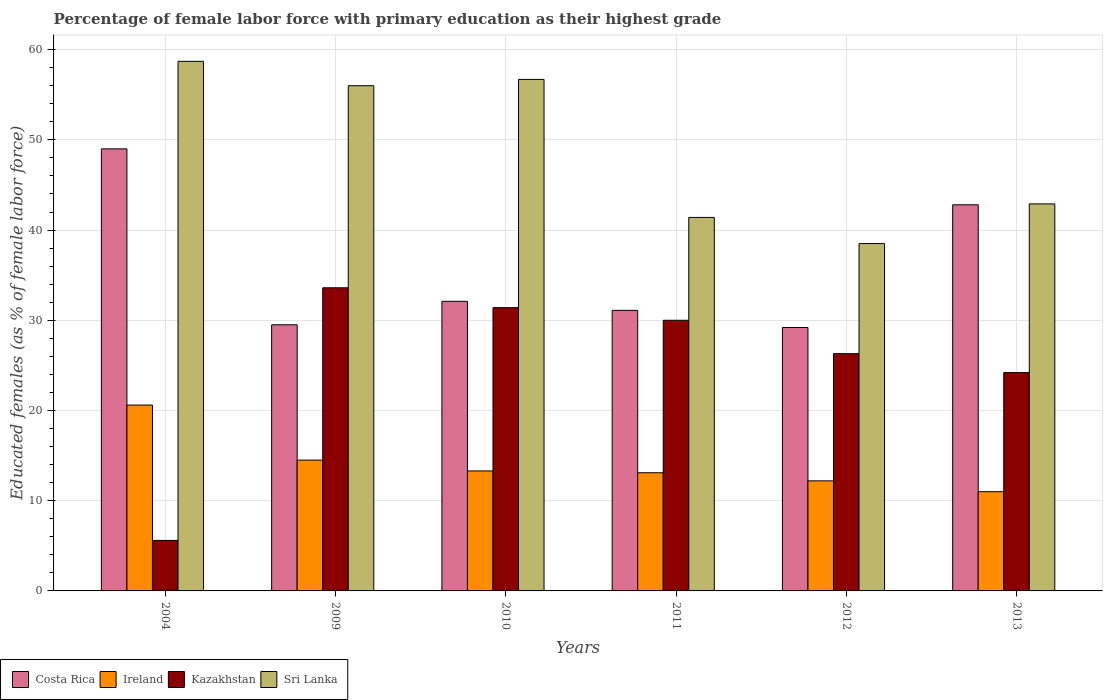How many groups of bars are there?
Your response must be concise. 6. What is the label of the 3rd group of bars from the left?
Your response must be concise. 2010. In how many cases, is the number of bars for a given year not equal to the number of legend labels?
Provide a succinct answer. 0. What is the percentage of female labor force with primary education in Costa Rica in 2010?
Keep it short and to the point. 32.1. Across all years, what is the maximum percentage of female labor force with primary education in Sri Lanka?
Keep it short and to the point. 58.7. Across all years, what is the minimum percentage of female labor force with primary education in Kazakhstan?
Provide a succinct answer. 5.6. In which year was the percentage of female labor force with primary education in Kazakhstan maximum?
Give a very brief answer. 2009. In which year was the percentage of female labor force with primary education in Costa Rica minimum?
Your answer should be compact. 2012. What is the total percentage of female labor force with primary education in Ireland in the graph?
Your answer should be compact. 84.7. What is the difference between the percentage of female labor force with primary education in Ireland in 2010 and that in 2011?
Offer a terse response. 0.2. What is the difference between the percentage of female labor force with primary education in Ireland in 2011 and the percentage of female labor force with primary education in Costa Rica in 2004?
Give a very brief answer. -35.9. What is the average percentage of female labor force with primary education in Costa Rica per year?
Offer a terse response. 35.62. In the year 2004, what is the difference between the percentage of female labor force with primary education in Sri Lanka and percentage of female labor force with primary education in Ireland?
Offer a terse response. 38.1. In how many years, is the percentage of female labor force with primary education in Ireland greater than 26 %?
Give a very brief answer. 0. What is the ratio of the percentage of female labor force with primary education in Sri Lanka in 2009 to that in 2011?
Provide a succinct answer. 1.35. Is the difference between the percentage of female labor force with primary education in Sri Lanka in 2009 and 2010 greater than the difference between the percentage of female labor force with primary education in Ireland in 2009 and 2010?
Provide a succinct answer. No. What is the difference between the highest and the second highest percentage of female labor force with primary education in Costa Rica?
Your answer should be very brief. 6.2. What is the difference between the highest and the lowest percentage of female labor force with primary education in Ireland?
Ensure brevity in your answer.  9.6. Is the sum of the percentage of female labor force with primary education in Sri Lanka in 2004 and 2010 greater than the maximum percentage of female labor force with primary education in Kazakhstan across all years?
Your response must be concise. Yes. Is it the case that in every year, the sum of the percentage of female labor force with primary education in Costa Rica and percentage of female labor force with primary education in Kazakhstan is greater than the sum of percentage of female labor force with primary education in Sri Lanka and percentage of female labor force with primary education in Ireland?
Keep it short and to the point. Yes. What does the 1st bar from the right in 2013 represents?
Provide a short and direct response. Sri Lanka. How many bars are there?
Your answer should be compact. 24. What is the difference between two consecutive major ticks on the Y-axis?
Ensure brevity in your answer.  10. Does the graph contain grids?
Keep it short and to the point. Yes. Where does the legend appear in the graph?
Give a very brief answer. Bottom left. How many legend labels are there?
Offer a very short reply. 4. How are the legend labels stacked?
Give a very brief answer. Horizontal. What is the title of the graph?
Your answer should be very brief. Percentage of female labor force with primary education as their highest grade. What is the label or title of the X-axis?
Make the answer very short. Years. What is the label or title of the Y-axis?
Ensure brevity in your answer.  Educated females (as % of female labor force). What is the Educated females (as % of female labor force) of Ireland in 2004?
Ensure brevity in your answer.  20.6. What is the Educated females (as % of female labor force) of Kazakhstan in 2004?
Provide a short and direct response. 5.6. What is the Educated females (as % of female labor force) of Sri Lanka in 2004?
Offer a very short reply. 58.7. What is the Educated females (as % of female labor force) in Costa Rica in 2009?
Offer a terse response. 29.5. What is the Educated females (as % of female labor force) of Kazakhstan in 2009?
Provide a short and direct response. 33.6. What is the Educated females (as % of female labor force) of Costa Rica in 2010?
Give a very brief answer. 32.1. What is the Educated females (as % of female labor force) of Ireland in 2010?
Offer a terse response. 13.3. What is the Educated females (as % of female labor force) of Kazakhstan in 2010?
Give a very brief answer. 31.4. What is the Educated females (as % of female labor force) of Sri Lanka in 2010?
Keep it short and to the point. 56.7. What is the Educated females (as % of female labor force) in Costa Rica in 2011?
Provide a short and direct response. 31.1. What is the Educated females (as % of female labor force) in Ireland in 2011?
Make the answer very short. 13.1. What is the Educated females (as % of female labor force) in Kazakhstan in 2011?
Your response must be concise. 30. What is the Educated females (as % of female labor force) in Sri Lanka in 2011?
Make the answer very short. 41.4. What is the Educated females (as % of female labor force) in Costa Rica in 2012?
Make the answer very short. 29.2. What is the Educated females (as % of female labor force) of Ireland in 2012?
Ensure brevity in your answer.  12.2. What is the Educated females (as % of female labor force) in Kazakhstan in 2012?
Provide a short and direct response. 26.3. What is the Educated females (as % of female labor force) in Sri Lanka in 2012?
Your answer should be compact. 38.5. What is the Educated females (as % of female labor force) of Costa Rica in 2013?
Make the answer very short. 42.8. What is the Educated females (as % of female labor force) in Kazakhstan in 2013?
Your answer should be very brief. 24.2. What is the Educated females (as % of female labor force) in Sri Lanka in 2013?
Provide a succinct answer. 42.9. Across all years, what is the maximum Educated females (as % of female labor force) of Ireland?
Provide a succinct answer. 20.6. Across all years, what is the maximum Educated females (as % of female labor force) of Kazakhstan?
Provide a short and direct response. 33.6. Across all years, what is the maximum Educated females (as % of female labor force) of Sri Lanka?
Your answer should be very brief. 58.7. Across all years, what is the minimum Educated females (as % of female labor force) of Costa Rica?
Your response must be concise. 29.2. Across all years, what is the minimum Educated females (as % of female labor force) in Ireland?
Your response must be concise. 11. Across all years, what is the minimum Educated females (as % of female labor force) in Kazakhstan?
Offer a terse response. 5.6. Across all years, what is the minimum Educated females (as % of female labor force) of Sri Lanka?
Provide a short and direct response. 38.5. What is the total Educated females (as % of female labor force) in Costa Rica in the graph?
Provide a succinct answer. 213.7. What is the total Educated females (as % of female labor force) in Ireland in the graph?
Offer a terse response. 84.7. What is the total Educated females (as % of female labor force) of Kazakhstan in the graph?
Give a very brief answer. 151.1. What is the total Educated females (as % of female labor force) of Sri Lanka in the graph?
Your answer should be compact. 294.2. What is the difference between the Educated females (as % of female labor force) of Sri Lanka in 2004 and that in 2009?
Provide a short and direct response. 2.7. What is the difference between the Educated females (as % of female labor force) of Costa Rica in 2004 and that in 2010?
Your answer should be compact. 16.9. What is the difference between the Educated females (as % of female labor force) in Ireland in 2004 and that in 2010?
Offer a very short reply. 7.3. What is the difference between the Educated females (as % of female labor force) in Kazakhstan in 2004 and that in 2010?
Provide a succinct answer. -25.8. What is the difference between the Educated females (as % of female labor force) in Sri Lanka in 2004 and that in 2010?
Offer a very short reply. 2. What is the difference between the Educated females (as % of female labor force) of Ireland in 2004 and that in 2011?
Make the answer very short. 7.5. What is the difference between the Educated females (as % of female labor force) of Kazakhstan in 2004 and that in 2011?
Keep it short and to the point. -24.4. What is the difference between the Educated females (as % of female labor force) of Sri Lanka in 2004 and that in 2011?
Your answer should be compact. 17.3. What is the difference between the Educated females (as % of female labor force) of Costa Rica in 2004 and that in 2012?
Keep it short and to the point. 19.8. What is the difference between the Educated females (as % of female labor force) in Kazakhstan in 2004 and that in 2012?
Give a very brief answer. -20.7. What is the difference between the Educated females (as % of female labor force) in Sri Lanka in 2004 and that in 2012?
Make the answer very short. 20.2. What is the difference between the Educated females (as % of female labor force) of Kazakhstan in 2004 and that in 2013?
Your answer should be very brief. -18.6. What is the difference between the Educated females (as % of female labor force) of Sri Lanka in 2004 and that in 2013?
Provide a succinct answer. 15.8. What is the difference between the Educated females (as % of female labor force) of Costa Rica in 2009 and that in 2010?
Offer a terse response. -2.6. What is the difference between the Educated females (as % of female labor force) of Ireland in 2009 and that in 2010?
Ensure brevity in your answer.  1.2. What is the difference between the Educated females (as % of female labor force) in Sri Lanka in 2009 and that in 2010?
Your response must be concise. -0.7. What is the difference between the Educated females (as % of female labor force) in Costa Rica in 2009 and that in 2011?
Your answer should be compact. -1.6. What is the difference between the Educated females (as % of female labor force) of Kazakhstan in 2009 and that in 2011?
Your answer should be compact. 3.6. What is the difference between the Educated females (as % of female labor force) of Sri Lanka in 2009 and that in 2011?
Give a very brief answer. 14.6. What is the difference between the Educated females (as % of female labor force) in Ireland in 2009 and that in 2012?
Provide a succinct answer. 2.3. What is the difference between the Educated females (as % of female labor force) of Kazakhstan in 2009 and that in 2012?
Give a very brief answer. 7.3. What is the difference between the Educated females (as % of female labor force) in Sri Lanka in 2009 and that in 2012?
Your response must be concise. 17.5. What is the difference between the Educated females (as % of female labor force) in Costa Rica in 2009 and that in 2013?
Offer a very short reply. -13.3. What is the difference between the Educated females (as % of female labor force) in Sri Lanka in 2009 and that in 2013?
Make the answer very short. 13.1. What is the difference between the Educated females (as % of female labor force) in Costa Rica in 2010 and that in 2011?
Provide a succinct answer. 1. What is the difference between the Educated females (as % of female labor force) of Kazakhstan in 2010 and that in 2011?
Make the answer very short. 1.4. What is the difference between the Educated females (as % of female labor force) of Costa Rica in 2010 and that in 2012?
Make the answer very short. 2.9. What is the difference between the Educated females (as % of female labor force) in Ireland in 2010 and that in 2013?
Provide a short and direct response. 2.3. What is the difference between the Educated females (as % of female labor force) of Kazakhstan in 2010 and that in 2013?
Offer a terse response. 7.2. What is the difference between the Educated females (as % of female labor force) in Kazakhstan in 2011 and that in 2012?
Your answer should be compact. 3.7. What is the difference between the Educated females (as % of female labor force) in Sri Lanka in 2011 and that in 2012?
Provide a succinct answer. 2.9. What is the difference between the Educated females (as % of female labor force) of Ireland in 2011 and that in 2013?
Give a very brief answer. 2.1. What is the difference between the Educated females (as % of female labor force) of Costa Rica in 2004 and the Educated females (as % of female labor force) of Ireland in 2009?
Ensure brevity in your answer.  34.5. What is the difference between the Educated females (as % of female labor force) in Costa Rica in 2004 and the Educated females (as % of female labor force) in Sri Lanka in 2009?
Your response must be concise. -7. What is the difference between the Educated females (as % of female labor force) of Ireland in 2004 and the Educated females (as % of female labor force) of Kazakhstan in 2009?
Keep it short and to the point. -13. What is the difference between the Educated females (as % of female labor force) of Ireland in 2004 and the Educated females (as % of female labor force) of Sri Lanka in 2009?
Offer a terse response. -35.4. What is the difference between the Educated females (as % of female labor force) of Kazakhstan in 2004 and the Educated females (as % of female labor force) of Sri Lanka in 2009?
Offer a very short reply. -50.4. What is the difference between the Educated females (as % of female labor force) of Costa Rica in 2004 and the Educated females (as % of female labor force) of Ireland in 2010?
Provide a short and direct response. 35.7. What is the difference between the Educated females (as % of female labor force) of Ireland in 2004 and the Educated females (as % of female labor force) of Kazakhstan in 2010?
Your answer should be very brief. -10.8. What is the difference between the Educated females (as % of female labor force) of Ireland in 2004 and the Educated females (as % of female labor force) of Sri Lanka in 2010?
Your answer should be compact. -36.1. What is the difference between the Educated females (as % of female labor force) in Kazakhstan in 2004 and the Educated females (as % of female labor force) in Sri Lanka in 2010?
Offer a terse response. -51.1. What is the difference between the Educated females (as % of female labor force) in Costa Rica in 2004 and the Educated females (as % of female labor force) in Ireland in 2011?
Give a very brief answer. 35.9. What is the difference between the Educated females (as % of female labor force) of Ireland in 2004 and the Educated females (as % of female labor force) of Sri Lanka in 2011?
Your response must be concise. -20.8. What is the difference between the Educated females (as % of female labor force) of Kazakhstan in 2004 and the Educated females (as % of female labor force) of Sri Lanka in 2011?
Offer a very short reply. -35.8. What is the difference between the Educated females (as % of female labor force) of Costa Rica in 2004 and the Educated females (as % of female labor force) of Ireland in 2012?
Provide a succinct answer. 36.8. What is the difference between the Educated females (as % of female labor force) in Costa Rica in 2004 and the Educated females (as % of female labor force) in Kazakhstan in 2012?
Keep it short and to the point. 22.7. What is the difference between the Educated females (as % of female labor force) of Costa Rica in 2004 and the Educated females (as % of female labor force) of Sri Lanka in 2012?
Your answer should be compact. 10.5. What is the difference between the Educated females (as % of female labor force) of Ireland in 2004 and the Educated females (as % of female labor force) of Sri Lanka in 2012?
Provide a succinct answer. -17.9. What is the difference between the Educated females (as % of female labor force) in Kazakhstan in 2004 and the Educated females (as % of female labor force) in Sri Lanka in 2012?
Your answer should be compact. -32.9. What is the difference between the Educated females (as % of female labor force) in Costa Rica in 2004 and the Educated females (as % of female labor force) in Kazakhstan in 2013?
Your response must be concise. 24.8. What is the difference between the Educated females (as % of female labor force) in Ireland in 2004 and the Educated females (as % of female labor force) in Kazakhstan in 2013?
Ensure brevity in your answer.  -3.6. What is the difference between the Educated females (as % of female labor force) in Ireland in 2004 and the Educated females (as % of female labor force) in Sri Lanka in 2013?
Provide a short and direct response. -22.3. What is the difference between the Educated females (as % of female labor force) in Kazakhstan in 2004 and the Educated females (as % of female labor force) in Sri Lanka in 2013?
Ensure brevity in your answer.  -37.3. What is the difference between the Educated females (as % of female labor force) in Costa Rica in 2009 and the Educated females (as % of female labor force) in Ireland in 2010?
Provide a succinct answer. 16.2. What is the difference between the Educated females (as % of female labor force) in Costa Rica in 2009 and the Educated females (as % of female labor force) in Sri Lanka in 2010?
Your response must be concise. -27.2. What is the difference between the Educated females (as % of female labor force) in Ireland in 2009 and the Educated females (as % of female labor force) in Kazakhstan in 2010?
Provide a short and direct response. -16.9. What is the difference between the Educated females (as % of female labor force) in Ireland in 2009 and the Educated females (as % of female labor force) in Sri Lanka in 2010?
Provide a short and direct response. -42.2. What is the difference between the Educated females (as % of female labor force) in Kazakhstan in 2009 and the Educated females (as % of female labor force) in Sri Lanka in 2010?
Your response must be concise. -23.1. What is the difference between the Educated females (as % of female labor force) in Costa Rica in 2009 and the Educated females (as % of female labor force) in Ireland in 2011?
Your answer should be compact. 16.4. What is the difference between the Educated females (as % of female labor force) in Costa Rica in 2009 and the Educated females (as % of female labor force) in Sri Lanka in 2011?
Keep it short and to the point. -11.9. What is the difference between the Educated females (as % of female labor force) of Ireland in 2009 and the Educated females (as % of female labor force) of Kazakhstan in 2011?
Offer a very short reply. -15.5. What is the difference between the Educated females (as % of female labor force) in Ireland in 2009 and the Educated females (as % of female labor force) in Sri Lanka in 2011?
Your answer should be compact. -26.9. What is the difference between the Educated females (as % of female labor force) of Kazakhstan in 2009 and the Educated females (as % of female labor force) of Sri Lanka in 2011?
Provide a short and direct response. -7.8. What is the difference between the Educated females (as % of female labor force) in Costa Rica in 2009 and the Educated females (as % of female labor force) in Sri Lanka in 2012?
Your answer should be very brief. -9. What is the difference between the Educated females (as % of female labor force) in Ireland in 2009 and the Educated females (as % of female labor force) in Sri Lanka in 2012?
Your answer should be very brief. -24. What is the difference between the Educated females (as % of female labor force) in Costa Rica in 2009 and the Educated females (as % of female labor force) in Ireland in 2013?
Give a very brief answer. 18.5. What is the difference between the Educated females (as % of female labor force) of Costa Rica in 2009 and the Educated females (as % of female labor force) of Kazakhstan in 2013?
Your answer should be very brief. 5.3. What is the difference between the Educated females (as % of female labor force) in Costa Rica in 2009 and the Educated females (as % of female labor force) in Sri Lanka in 2013?
Ensure brevity in your answer.  -13.4. What is the difference between the Educated females (as % of female labor force) in Ireland in 2009 and the Educated females (as % of female labor force) in Kazakhstan in 2013?
Your answer should be compact. -9.7. What is the difference between the Educated females (as % of female labor force) of Ireland in 2009 and the Educated females (as % of female labor force) of Sri Lanka in 2013?
Offer a terse response. -28.4. What is the difference between the Educated females (as % of female labor force) in Kazakhstan in 2009 and the Educated females (as % of female labor force) in Sri Lanka in 2013?
Ensure brevity in your answer.  -9.3. What is the difference between the Educated females (as % of female labor force) in Costa Rica in 2010 and the Educated females (as % of female labor force) in Ireland in 2011?
Ensure brevity in your answer.  19. What is the difference between the Educated females (as % of female labor force) of Costa Rica in 2010 and the Educated females (as % of female labor force) of Kazakhstan in 2011?
Provide a succinct answer. 2.1. What is the difference between the Educated females (as % of female labor force) in Costa Rica in 2010 and the Educated females (as % of female labor force) in Sri Lanka in 2011?
Your response must be concise. -9.3. What is the difference between the Educated females (as % of female labor force) of Ireland in 2010 and the Educated females (as % of female labor force) of Kazakhstan in 2011?
Provide a succinct answer. -16.7. What is the difference between the Educated females (as % of female labor force) of Ireland in 2010 and the Educated females (as % of female labor force) of Sri Lanka in 2011?
Provide a short and direct response. -28.1. What is the difference between the Educated females (as % of female labor force) in Costa Rica in 2010 and the Educated females (as % of female labor force) in Ireland in 2012?
Keep it short and to the point. 19.9. What is the difference between the Educated females (as % of female labor force) of Costa Rica in 2010 and the Educated females (as % of female labor force) of Kazakhstan in 2012?
Give a very brief answer. 5.8. What is the difference between the Educated females (as % of female labor force) of Costa Rica in 2010 and the Educated females (as % of female labor force) of Sri Lanka in 2012?
Your answer should be compact. -6.4. What is the difference between the Educated females (as % of female labor force) of Ireland in 2010 and the Educated females (as % of female labor force) of Kazakhstan in 2012?
Your answer should be very brief. -13. What is the difference between the Educated females (as % of female labor force) of Ireland in 2010 and the Educated females (as % of female labor force) of Sri Lanka in 2012?
Your answer should be compact. -25.2. What is the difference between the Educated females (as % of female labor force) of Kazakhstan in 2010 and the Educated females (as % of female labor force) of Sri Lanka in 2012?
Offer a terse response. -7.1. What is the difference between the Educated females (as % of female labor force) of Costa Rica in 2010 and the Educated females (as % of female labor force) of Ireland in 2013?
Make the answer very short. 21.1. What is the difference between the Educated females (as % of female labor force) in Ireland in 2010 and the Educated females (as % of female labor force) in Kazakhstan in 2013?
Your answer should be compact. -10.9. What is the difference between the Educated females (as % of female labor force) in Ireland in 2010 and the Educated females (as % of female labor force) in Sri Lanka in 2013?
Your answer should be very brief. -29.6. What is the difference between the Educated females (as % of female labor force) in Kazakhstan in 2010 and the Educated females (as % of female labor force) in Sri Lanka in 2013?
Your answer should be compact. -11.5. What is the difference between the Educated females (as % of female labor force) in Costa Rica in 2011 and the Educated females (as % of female labor force) in Ireland in 2012?
Ensure brevity in your answer.  18.9. What is the difference between the Educated females (as % of female labor force) of Costa Rica in 2011 and the Educated females (as % of female labor force) of Kazakhstan in 2012?
Your response must be concise. 4.8. What is the difference between the Educated females (as % of female labor force) in Costa Rica in 2011 and the Educated females (as % of female labor force) in Sri Lanka in 2012?
Make the answer very short. -7.4. What is the difference between the Educated females (as % of female labor force) in Ireland in 2011 and the Educated females (as % of female labor force) in Sri Lanka in 2012?
Make the answer very short. -25.4. What is the difference between the Educated females (as % of female labor force) of Costa Rica in 2011 and the Educated females (as % of female labor force) of Ireland in 2013?
Provide a succinct answer. 20.1. What is the difference between the Educated females (as % of female labor force) in Costa Rica in 2011 and the Educated females (as % of female labor force) in Kazakhstan in 2013?
Provide a succinct answer. 6.9. What is the difference between the Educated females (as % of female labor force) in Costa Rica in 2011 and the Educated females (as % of female labor force) in Sri Lanka in 2013?
Make the answer very short. -11.8. What is the difference between the Educated females (as % of female labor force) in Ireland in 2011 and the Educated females (as % of female labor force) in Kazakhstan in 2013?
Provide a succinct answer. -11.1. What is the difference between the Educated females (as % of female labor force) of Ireland in 2011 and the Educated females (as % of female labor force) of Sri Lanka in 2013?
Ensure brevity in your answer.  -29.8. What is the difference between the Educated females (as % of female labor force) of Costa Rica in 2012 and the Educated females (as % of female labor force) of Ireland in 2013?
Offer a terse response. 18.2. What is the difference between the Educated females (as % of female labor force) in Costa Rica in 2012 and the Educated females (as % of female labor force) in Kazakhstan in 2013?
Offer a very short reply. 5. What is the difference between the Educated females (as % of female labor force) in Costa Rica in 2012 and the Educated females (as % of female labor force) in Sri Lanka in 2013?
Ensure brevity in your answer.  -13.7. What is the difference between the Educated females (as % of female labor force) of Ireland in 2012 and the Educated females (as % of female labor force) of Kazakhstan in 2013?
Your answer should be very brief. -12. What is the difference between the Educated females (as % of female labor force) of Ireland in 2012 and the Educated females (as % of female labor force) of Sri Lanka in 2013?
Provide a short and direct response. -30.7. What is the difference between the Educated females (as % of female labor force) of Kazakhstan in 2012 and the Educated females (as % of female labor force) of Sri Lanka in 2013?
Provide a succinct answer. -16.6. What is the average Educated females (as % of female labor force) of Costa Rica per year?
Offer a very short reply. 35.62. What is the average Educated females (as % of female labor force) of Ireland per year?
Make the answer very short. 14.12. What is the average Educated females (as % of female labor force) in Kazakhstan per year?
Offer a very short reply. 25.18. What is the average Educated females (as % of female labor force) in Sri Lanka per year?
Your answer should be compact. 49.03. In the year 2004, what is the difference between the Educated females (as % of female labor force) of Costa Rica and Educated females (as % of female labor force) of Ireland?
Offer a very short reply. 28.4. In the year 2004, what is the difference between the Educated females (as % of female labor force) in Costa Rica and Educated females (as % of female labor force) in Kazakhstan?
Your answer should be very brief. 43.4. In the year 2004, what is the difference between the Educated females (as % of female labor force) of Ireland and Educated females (as % of female labor force) of Kazakhstan?
Provide a succinct answer. 15. In the year 2004, what is the difference between the Educated females (as % of female labor force) of Ireland and Educated females (as % of female labor force) of Sri Lanka?
Give a very brief answer. -38.1. In the year 2004, what is the difference between the Educated females (as % of female labor force) in Kazakhstan and Educated females (as % of female labor force) in Sri Lanka?
Offer a terse response. -53.1. In the year 2009, what is the difference between the Educated females (as % of female labor force) in Costa Rica and Educated females (as % of female labor force) in Ireland?
Provide a succinct answer. 15. In the year 2009, what is the difference between the Educated females (as % of female labor force) of Costa Rica and Educated females (as % of female labor force) of Sri Lanka?
Provide a succinct answer. -26.5. In the year 2009, what is the difference between the Educated females (as % of female labor force) of Ireland and Educated females (as % of female labor force) of Kazakhstan?
Make the answer very short. -19.1. In the year 2009, what is the difference between the Educated females (as % of female labor force) of Ireland and Educated females (as % of female labor force) of Sri Lanka?
Your response must be concise. -41.5. In the year 2009, what is the difference between the Educated females (as % of female labor force) of Kazakhstan and Educated females (as % of female labor force) of Sri Lanka?
Give a very brief answer. -22.4. In the year 2010, what is the difference between the Educated females (as % of female labor force) in Costa Rica and Educated females (as % of female labor force) in Ireland?
Provide a short and direct response. 18.8. In the year 2010, what is the difference between the Educated females (as % of female labor force) of Costa Rica and Educated females (as % of female labor force) of Sri Lanka?
Give a very brief answer. -24.6. In the year 2010, what is the difference between the Educated females (as % of female labor force) of Ireland and Educated females (as % of female labor force) of Kazakhstan?
Make the answer very short. -18.1. In the year 2010, what is the difference between the Educated females (as % of female labor force) of Ireland and Educated females (as % of female labor force) of Sri Lanka?
Give a very brief answer. -43.4. In the year 2010, what is the difference between the Educated females (as % of female labor force) in Kazakhstan and Educated females (as % of female labor force) in Sri Lanka?
Your response must be concise. -25.3. In the year 2011, what is the difference between the Educated females (as % of female labor force) of Costa Rica and Educated females (as % of female labor force) of Kazakhstan?
Your response must be concise. 1.1. In the year 2011, what is the difference between the Educated females (as % of female labor force) of Ireland and Educated females (as % of female labor force) of Kazakhstan?
Provide a succinct answer. -16.9. In the year 2011, what is the difference between the Educated females (as % of female labor force) in Ireland and Educated females (as % of female labor force) in Sri Lanka?
Keep it short and to the point. -28.3. In the year 2011, what is the difference between the Educated females (as % of female labor force) of Kazakhstan and Educated females (as % of female labor force) of Sri Lanka?
Your response must be concise. -11.4. In the year 2012, what is the difference between the Educated females (as % of female labor force) of Costa Rica and Educated females (as % of female labor force) of Ireland?
Make the answer very short. 17. In the year 2012, what is the difference between the Educated females (as % of female labor force) of Ireland and Educated females (as % of female labor force) of Kazakhstan?
Keep it short and to the point. -14.1. In the year 2012, what is the difference between the Educated females (as % of female labor force) in Ireland and Educated females (as % of female labor force) in Sri Lanka?
Your answer should be very brief. -26.3. In the year 2013, what is the difference between the Educated females (as % of female labor force) in Costa Rica and Educated females (as % of female labor force) in Ireland?
Give a very brief answer. 31.8. In the year 2013, what is the difference between the Educated females (as % of female labor force) of Costa Rica and Educated females (as % of female labor force) of Sri Lanka?
Provide a succinct answer. -0.1. In the year 2013, what is the difference between the Educated females (as % of female labor force) in Ireland and Educated females (as % of female labor force) in Kazakhstan?
Give a very brief answer. -13.2. In the year 2013, what is the difference between the Educated females (as % of female labor force) of Ireland and Educated females (as % of female labor force) of Sri Lanka?
Make the answer very short. -31.9. In the year 2013, what is the difference between the Educated females (as % of female labor force) in Kazakhstan and Educated females (as % of female labor force) in Sri Lanka?
Ensure brevity in your answer.  -18.7. What is the ratio of the Educated females (as % of female labor force) in Costa Rica in 2004 to that in 2009?
Give a very brief answer. 1.66. What is the ratio of the Educated females (as % of female labor force) in Ireland in 2004 to that in 2009?
Your answer should be compact. 1.42. What is the ratio of the Educated females (as % of female labor force) in Sri Lanka in 2004 to that in 2009?
Your response must be concise. 1.05. What is the ratio of the Educated females (as % of female labor force) in Costa Rica in 2004 to that in 2010?
Offer a very short reply. 1.53. What is the ratio of the Educated females (as % of female labor force) of Ireland in 2004 to that in 2010?
Offer a terse response. 1.55. What is the ratio of the Educated females (as % of female labor force) of Kazakhstan in 2004 to that in 2010?
Your answer should be compact. 0.18. What is the ratio of the Educated females (as % of female labor force) in Sri Lanka in 2004 to that in 2010?
Offer a very short reply. 1.04. What is the ratio of the Educated females (as % of female labor force) in Costa Rica in 2004 to that in 2011?
Provide a short and direct response. 1.58. What is the ratio of the Educated females (as % of female labor force) in Ireland in 2004 to that in 2011?
Offer a terse response. 1.57. What is the ratio of the Educated females (as % of female labor force) of Kazakhstan in 2004 to that in 2011?
Make the answer very short. 0.19. What is the ratio of the Educated females (as % of female labor force) in Sri Lanka in 2004 to that in 2011?
Provide a short and direct response. 1.42. What is the ratio of the Educated females (as % of female labor force) in Costa Rica in 2004 to that in 2012?
Keep it short and to the point. 1.68. What is the ratio of the Educated females (as % of female labor force) in Ireland in 2004 to that in 2012?
Offer a very short reply. 1.69. What is the ratio of the Educated females (as % of female labor force) of Kazakhstan in 2004 to that in 2012?
Ensure brevity in your answer.  0.21. What is the ratio of the Educated females (as % of female labor force) in Sri Lanka in 2004 to that in 2012?
Your answer should be very brief. 1.52. What is the ratio of the Educated females (as % of female labor force) of Costa Rica in 2004 to that in 2013?
Offer a very short reply. 1.14. What is the ratio of the Educated females (as % of female labor force) in Ireland in 2004 to that in 2013?
Make the answer very short. 1.87. What is the ratio of the Educated females (as % of female labor force) in Kazakhstan in 2004 to that in 2013?
Keep it short and to the point. 0.23. What is the ratio of the Educated females (as % of female labor force) of Sri Lanka in 2004 to that in 2013?
Your response must be concise. 1.37. What is the ratio of the Educated females (as % of female labor force) in Costa Rica in 2009 to that in 2010?
Your answer should be very brief. 0.92. What is the ratio of the Educated females (as % of female labor force) in Ireland in 2009 to that in 2010?
Provide a short and direct response. 1.09. What is the ratio of the Educated females (as % of female labor force) of Kazakhstan in 2009 to that in 2010?
Give a very brief answer. 1.07. What is the ratio of the Educated females (as % of female labor force) in Costa Rica in 2009 to that in 2011?
Give a very brief answer. 0.95. What is the ratio of the Educated females (as % of female labor force) in Ireland in 2009 to that in 2011?
Make the answer very short. 1.11. What is the ratio of the Educated females (as % of female labor force) in Kazakhstan in 2009 to that in 2011?
Make the answer very short. 1.12. What is the ratio of the Educated females (as % of female labor force) of Sri Lanka in 2009 to that in 2011?
Give a very brief answer. 1.35. What is the ratio of the Educated females (as % of female labor force) of Costa Rica in 2009 to that in 2012?
Your response must be concise. 1.01. What is the ratio of the Educated females (as % of female labor force) in Ireland in 2009 to that in 2012?
Make the answer very short. 1.19. What is the ratio of the Educated females (as % of female labor force) of Kazakhstan in 2009 to that in 2012?
Give a very brief answer. 1.28. What is the ratio of the Educated females (as % of female labor force) of Sri Lanka in 2009 to that in 2012?
Offer a very short reply. 1.45. What is the ratio of the Educated females (as % of female labor force) of Costa Rica in 2009 to that in 2013?
Give a very brief answer. 0.69. What is the ratio of the Educated females (as % of female labor force) in Ireland in 2009 to that in 2013?
Provide a succinct answer. 1.32. What is the ratio of the Educated females (as % of female labor force) in Kazakhstan in 2009 to that in 2013?
Keep it short and to the point. 1.39. What is the ratio of the Educated females (as % of female labor force) in Sri Lanka in 2009 to that in 2013?
Your answer should be very brief. 1.31. What is the ratio of the Educated females (as % of female labor force) of Costa Rica in 2010 to that in 2011?
Your answer should be compact. 1.03. What is the ratio of the Educated females (as % of female labor force) in Ireland in 2010 to that in 2011?
Your answer should be very brief. 1.02. What is the ratio of the Educated females (as % of female labor force) in Kazakhstan in 2010 to that in 2011?
Keep it short and to the point. 1.05. What is the ratio of the Educated females (as % of female labor force) in Sri Lanka in 2010 to that in 2011?
Offer a terse response. 1.37. What is the ratio of the Educated females (as % of female labor force) of Costa Rica in 2010 to that in 2012?
Offer a terse response. 1.1. What is the ratio of the Educated females (as % of female labor force) of Ireland in 2010 to that in 2012?
Offer a terse response. 1.09. What is the ratio of the Educated females (as % of female labor force) of Kazakhstan in 2010 to that in 2012?
Your answer should be compact. 1.19. What is the ratio of the Educated females (as % of female labor force) of Sri Lanka in 2010 to that in 2012?
Offer a terse response. 1.47. What is the ratio of the Educated females (as % of female labor force) in Costa Rica in 2010 to that in 2013?
Keep it short and to the point. 0.75. What is the ratio of the Educated females (as % of female labor force) in Ireland in 2010 to that in 2013?
Provide a succinct answer. 1.21. What is the ratio of the Educated females (as % of female labor force) in Kazakhstan in 2010 to that in 2013?
Ensure brevity in your answer.  1.3. What is the ratio of the Educated females (as % of female labor force) in Sri Lanka in 2010 to that in 2013?
Provide a short and direct response. 1.32. What is the ratio of the Educated females (as % of female labor force) in Costa Rica in 2011 to that in 2012?
Your answer should be very brief. 1.07. What is the ratio of the Educated females (as % of female labor force) of Ireland in 2011 to that in 2012?
Keep it short and to the point. 1.07. What is the ratio of the Educated females (as % of female labor force) in Kazakhstan in 2011 to that in 2012?
Offer a terse response. 1.14. What is the ratio of the Educated females (as % of female labor force) of Sri Lanka in 2011 to that in 2012?
Make the answer very short. 1.08. What is the ratio of the Educated females (as % of female labor force) in Costa Rica in 2011 to that in 2013?
Your response must be concise. 0.73. What is the ratio of the Educated females (as % of female labor force) in Ireland in 2011 to that in 2013?
Offer a terse response. 1.19. What is the ratio of the Educated females (as % of female labor force) of Kazakhstan in 2011 to that in 2013?
Offer a terse response. 1.24. What is the ratio of the Educated females (as % of female labor force) in Sri Lanka in 2011 to that in 2013?
Ensure brevity in your answer.  0.96. What is the ratio of the Educated females (as % of female labor force) in Costa Rica in 2012 to that in 2013?
Provide a succinct answer. 0.68. What is the ratio of the Educated females (as % of female labor force) of Ireland in 2012 to that in 2013?
Offer a very short reply. 1.11. What is the ratio of the Educated females (as % of female labor force) in Kazakhstan in 2012 to that in 2013?
Provide a succinct answer. 1.09. What is the ratio of the Educated females (as % of female labor force) of Sri Lanka in 2012 to that in 2013?
Give a very brief answer. 0.9. What is the difference between the highest and the second highest Educated females (as % of female labor force) of Kazakhstan?
Offer a very short reply. 2.2. What is the difference between the highest and the second highest Educated females (as % of female labor force) of Sri Lanka?
Your answer should be compact. 2. What is the difference between the highest and the lowest Educated females (as % of female labor force) in Costa Rica?
Offer a terse response. 19.8. What is the difference between the highest and the lowest Educated females (as % of female labor force) of Sri Lanka?
Your answer should be very brief. 20.2. 